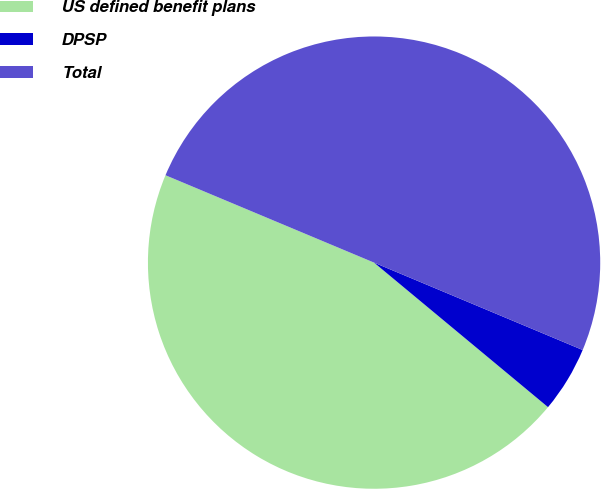Convert chart to OTSL. <chart><loc_0><loc_0><loc_500><loc_500><pie_chart><fcel>US defined benefit plans<fcel>DPSP<fcel>Total<nl><fcel>45.28%<fcel>4.72%<fcel>50.0%<nl></chart> 